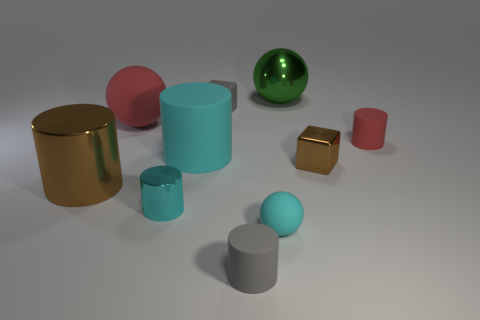Subtract all small balls. How many balls are left? 2 Subtract all purple balls. How many cyan cylinders are left? 2 Subtract 2 cylinders. How many cylinders are left? 3 Subtract all cyan cylinders. How many cylinders are left? 3 Subtract all gray balls. Subtract all yellow cubes. How many balls are left? 3 Add 5 small matte blocks. How many small matte blocks exist? 6 Subtract 0 blue cubes. How many objects are left? 10 Subtract all balls. How many objects are left? 7 Subtract all large red spheres. Subtract all big metallic things. How many objects are left? 7 Add 6 large green balls. How many large green balls are left? 7 